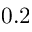Convert formula to latex. <formula><loc_0><loc_0><loc_500><loc_500>0 . 2</formula> 